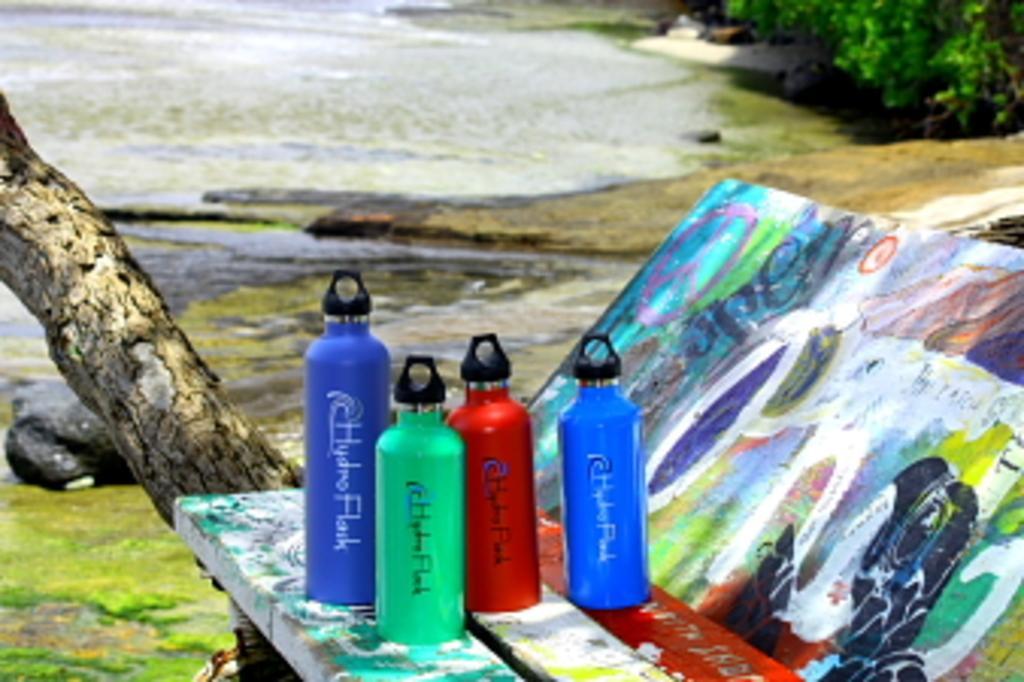In one or two sentences, can you explain what this image depicts? In this image I can see few water bottles which are red, blue and green in color on the colorful surface. In the background I can see the water, few trees and the ground. 